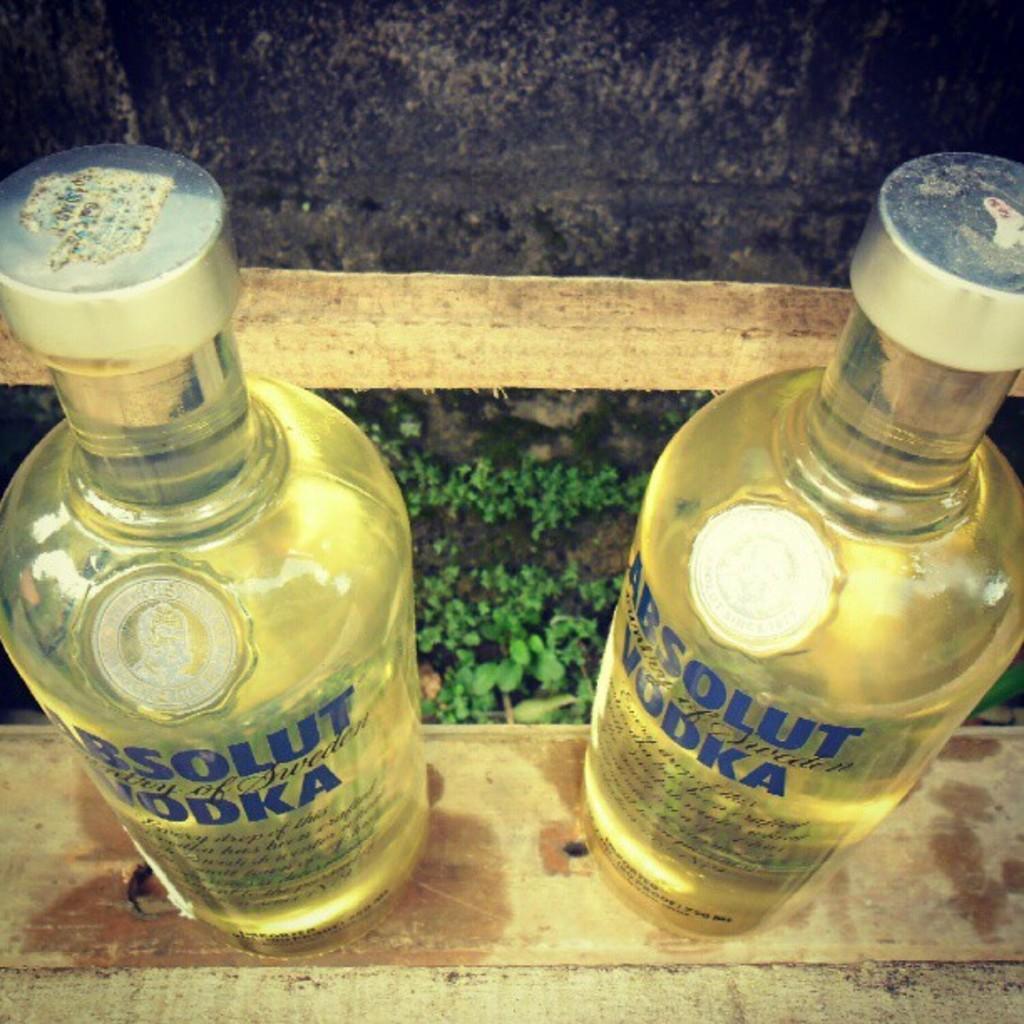What kind of liquor do the bottles have inside them?
Make the answer very short. Vodka. What is the brand name?
Provide a succinct answer. Absolut. 